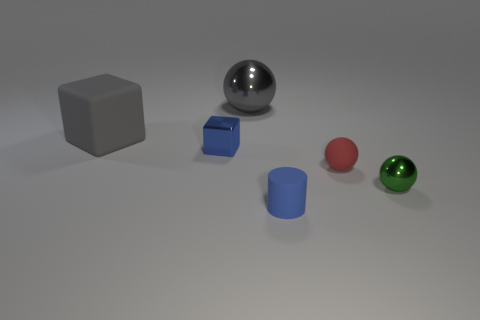Subtract all blue balls. Subtract all purple cylinders. How many balls are left? 3 Add 1 big metal objects. How many objects exist? 7 Subtract all cylinders. How many objects are left? 5 Add 2 big matte blocks. How many big matte blocks are left? 3 Add 5 cyan shiny balls. How many cyan shiny balls exist? 5 Subtract 0 yellow cylinders. How many objects are left? 6 Subtract all small brown cylinders. Subtract all gray cubes. How many objects are left? 5 